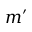Convert formula to latex. <formula><loc_0><loc_0><loc_500><loc_500>m ^ { \prime }</formula> 